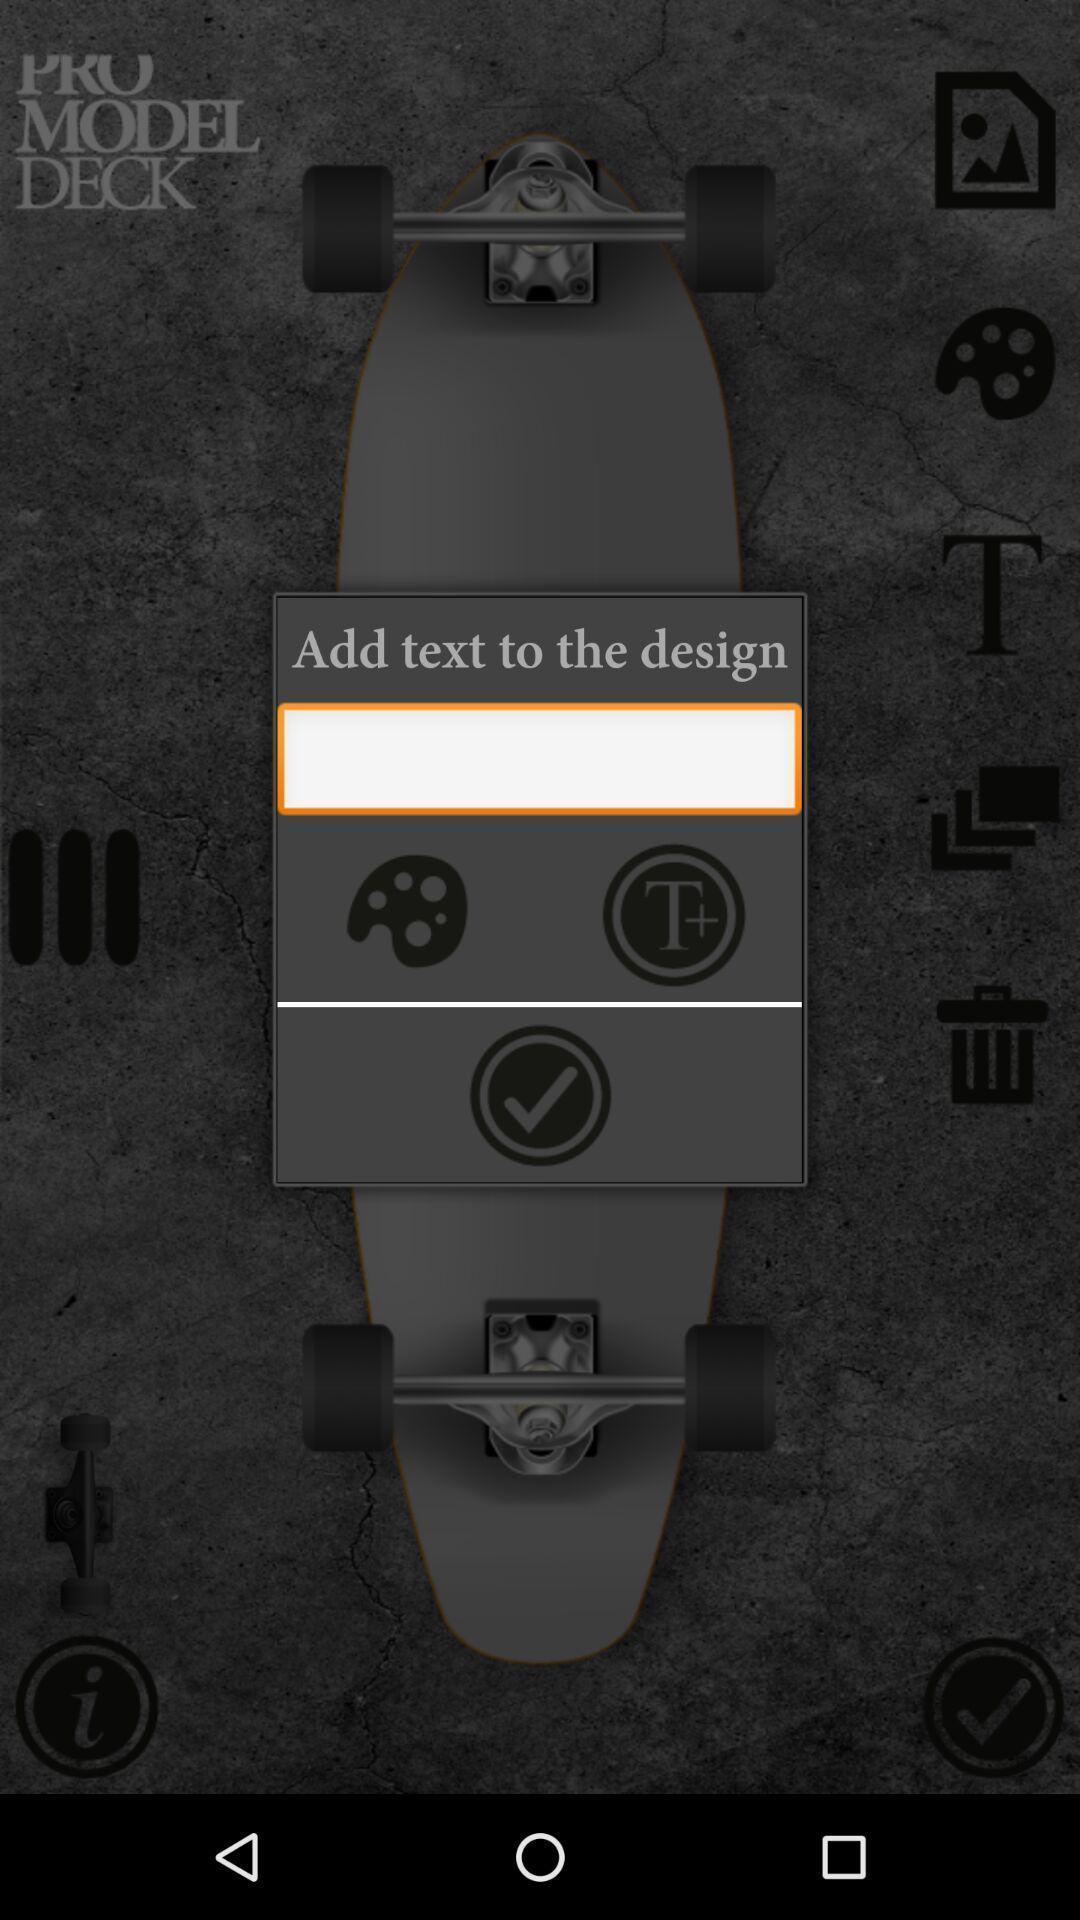Summarize the main components in this picture. Screen display add text to the design option. 